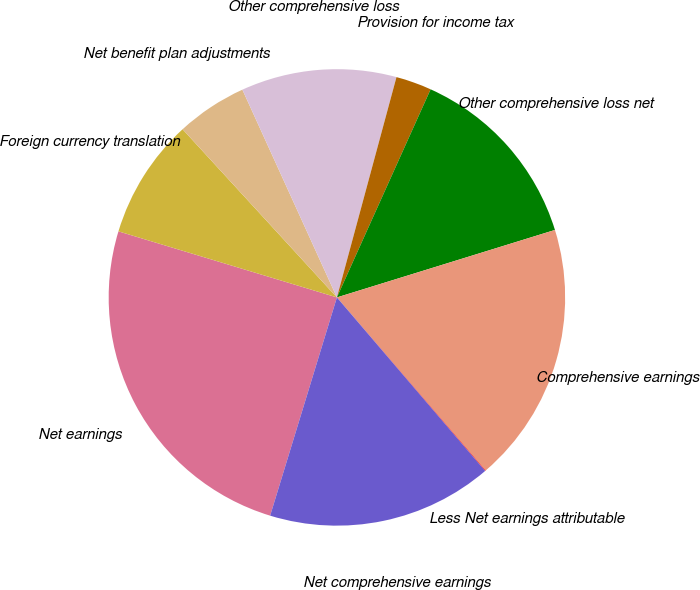<chart> <loc_0><loc_0><loc_500><loc_500><pie_chart><fcel>Net earnings<fcel>Foreign currency translation<fcel>Net benefit plan adjustments<fcel>Other comprehensive loss<fcel>Provision for income tax<fcel>Other comprehensive loss net<fcel>Comprehensive earnings<fcel>Less Net earnings attributable<fcel>Net comprehensive earnings<nl><fcel>24.95%<fcel>8.51%<fcel>5.02%<fcel>11.0%<fcel>2.53%<fcel>13.49%<fcel>18.48%<fcel>0.04%<fcel>15.98%<nl></chart> 